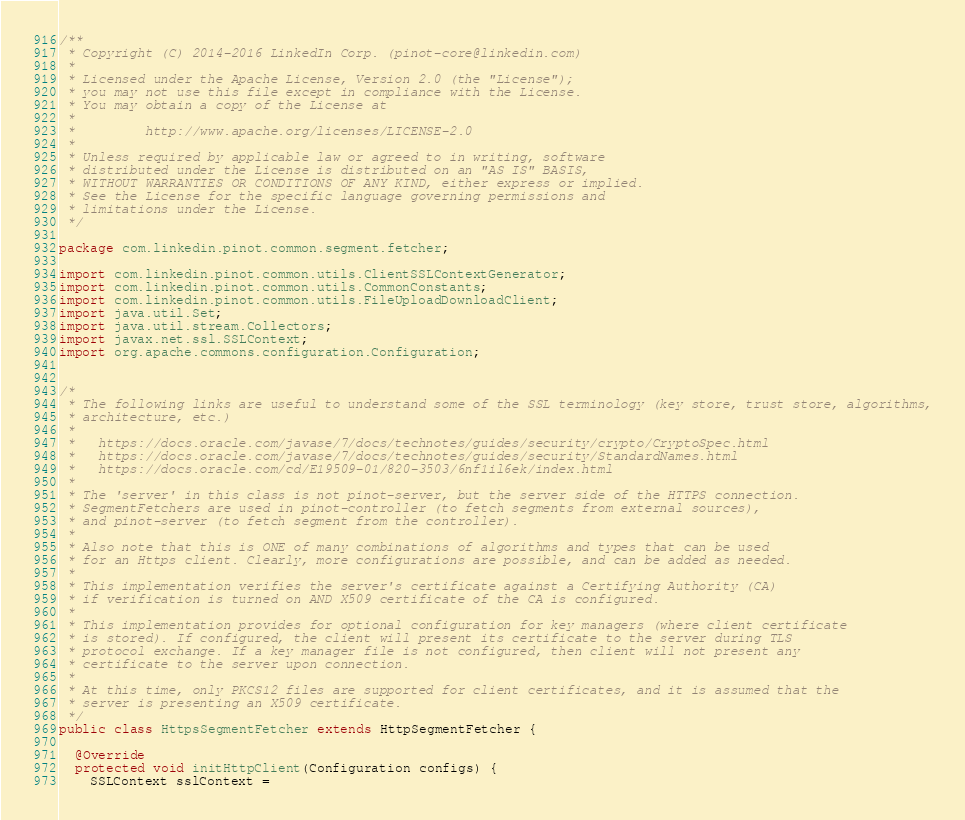<code> <loc_0><loc_0><loc_500><loc_500><_Java_>/**
 * Copyright (C) 2014-2016 LinkedIn Corp. (pinot-core@linkedin.com)
 *
 * Licensed under the Apache License, Version 2.0 (the "License");
 * you may not use this file except in compliance with the License.
 * You may obtain a copy of the License at
 *
 *         http://www.apache.org/licenses/LICENSE-2.0
 *
 * Unless required by applicable law or agreed to in writing, software
 * distributed under the License is distributed on an "AS IS" BASIS,
 * WITHOUT WARRANTIES OR CONDITIONS OF ANY KIND, either express or implied.
 * See the License for the specific language governing permissions and
 * limitations under the License.
 */

package com.linkedin.pinot.common.segment.fetcher;

import com.linkedin.pinot.common.utils.ClientSSLContextGenerator;
import com.linkedin.pinot.common.utils.CommonConstants;
import com.linkedin.pinot.common.utils.FileUploadDownloadClient;
import java.util.Set;
import java.util.stream.Collectors;
import javax.net.ssl.SSLContext;
import org.apache.commons.configuration.Configuration;


/*
 * The following links are useful to understand some of the SSL terminology (key store, trust store, algorithms,
 * architecture, etc.)
 *
 *   https://docs.oracle.com/javase/7/docs/technotes/guides/security/crypto/CryptoSpec.html
 *   https://docs.oracle.com/javase/7/docs/technotes/guides/security/StandardNames.html
 *   https://docs.oracle.com/cd/E19509-01/820-3503/6nf1il6ek/index.html
 *
 * The 'server' in this class is not pinot-server, but the server side of the HTTPS connection.
 * SegmentFetchers are used in pinot-controller (to fetch segments from external sources),
 * and pinot-server (to fetch segment from the controller).
 *
 * Also note that this is ONE of many combinations of algorithms and types that can be used
 * for an Https client. Clearly, more configurations are possible, and can be added as needed.
 *
 * This implementation verifies the server's certificate against a Certifying Authority (CA)
 * if verification is turned on AND X509 certificate of the CA is configured.
 *
 * This implementation provides for optional configuration for key managers (where client certificate
 * is stored). If configured, the client will present its certificate to the server during TLS
 * protocol exchange. If a key manager file is not configured, then client will not present any
 * certificate to the server upon connection.
 *
 * At this time, only PKCS12 files are supported for client certificates, and it is assumed that the
 * server is presenting an X509 certificate.
 */
public class HttpsSegmentFetcher extends HttpSegmentFetcher {

  @Override
  protected void initHttpClient(Configuration configs) {
    SSLContext sslContext =</code> 